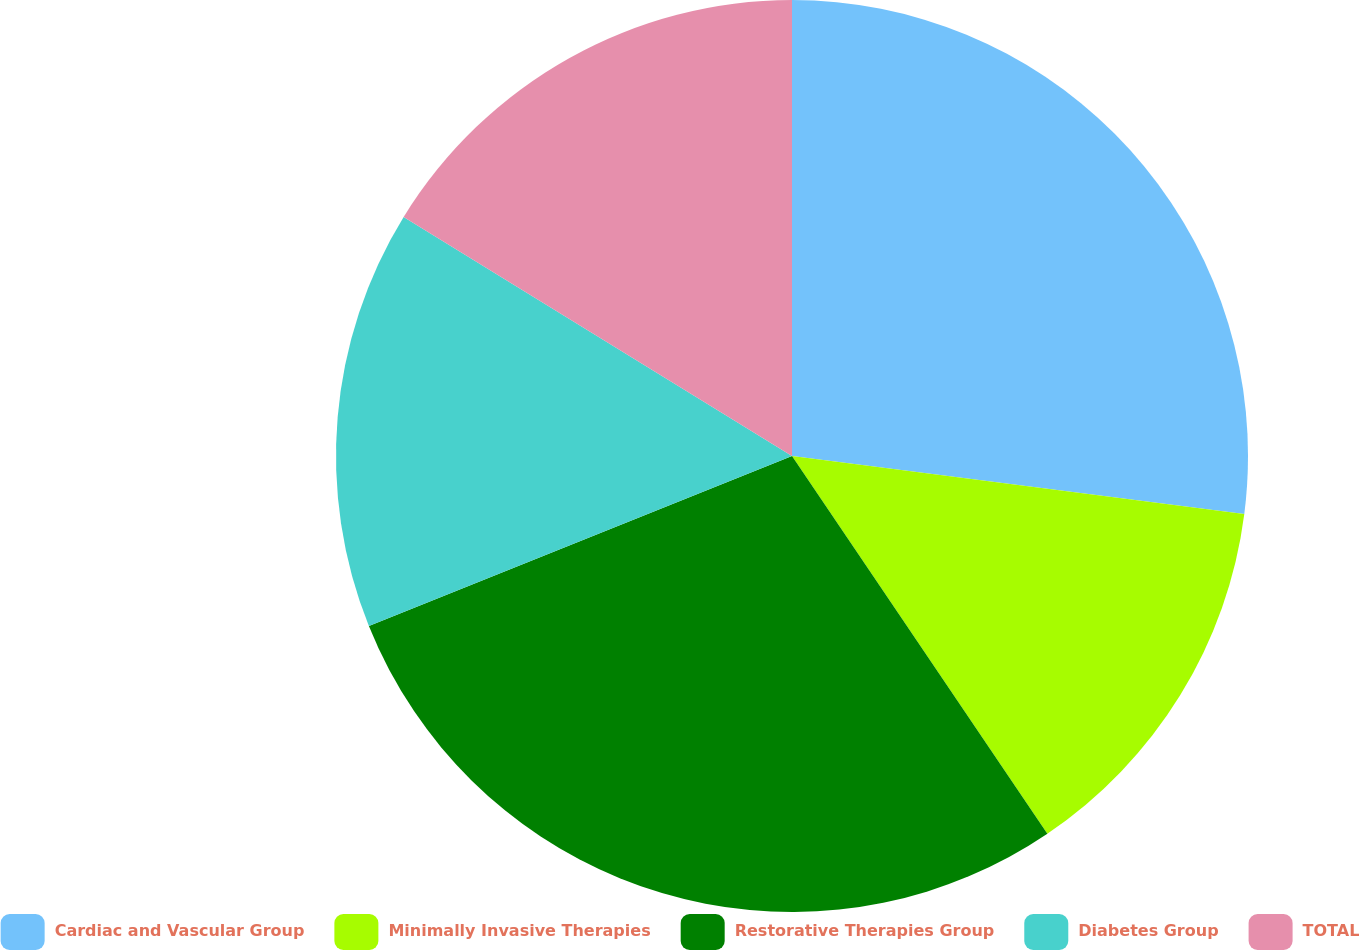<chart> <loc_0><loc_0><loc_500><loc_500><pie_chart><fcel>Cardiac and Vascular Group<fcel>Minimally Invasive Therapies<fcel>Restorative Therapies Group<fcel>Diabetes Group<fcel>TOTAL<nl><fcel>27.03%<fcel>13.51%<fcel>28.38%<fcel>14.86%<fcel>16.22%<nl></chart> 